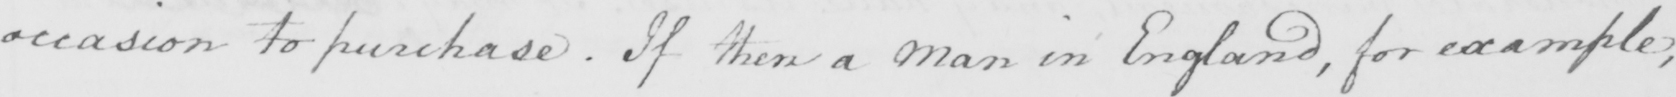What is written in this line of handwriting? occasion to purchase . If then a Man in England , for example , 